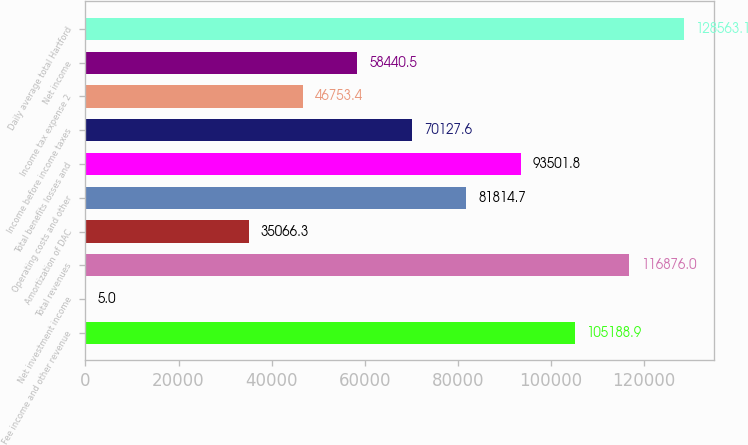Convert chart to OTSL. <chart><loc_0><loc_0><loc_500><loc_500><bar_chart><fcel>Fee income and other revenue<fcel>Net investment income<fcel>Total revenues<fcel>Amortization of DAC<fcel>Operating costs and other<fcel>Total benefits losses and<fcel>Income before income taxes<fcel>Income tax expense 2<fcel>Net income<fcel>Daily average total Hartford<nl><fcel>105189<fcel>5<fcel>116876<fcel>35066.3<fcel>81814.7<fcel>93501.8<fcel>70127.6<fcel>46753.4<fcel>58440.5<fcel>128563<nl></chart> 